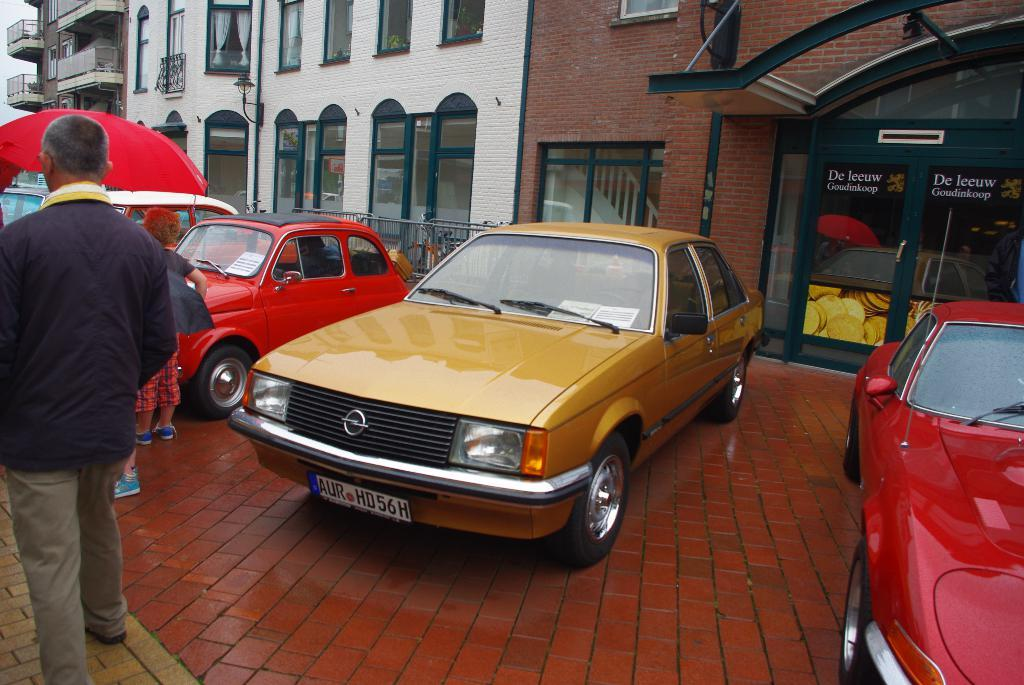What is the main subject in the center of the image? There are cars in the center of the image. What can be seen on the left side of the image? There are people on the left side of the image. What is visible in the background of the image? There are buildings in the background of the image. Can you tell me how many cows are grazing on the right side of the image? A: There are no cows present in the image; it features cars, people, and buildings. What type of laborer is working on the buildings in the image? There is no laborer visible in the image; it only shows cars, people, and buildings. 